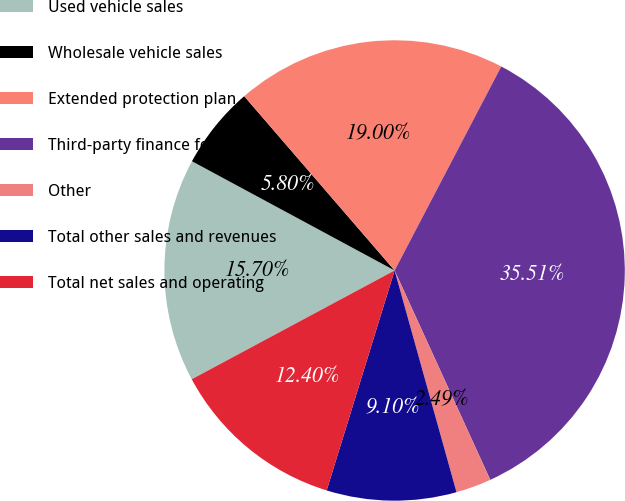Convert chart to OTSL. <chart><loc_0><loc_0><loc_500><loc_500><pie_chart><fcel>Used vehicle sales<fcel>Wholesale vehicle sales<fcel>Extended protection plan<fcel>Third-party finance fees net<fcel>Other<fcel>Total other sales and revenues<fcel>Total net sales and operating<nl><fcel>15.7%<fcel>5.8%<fcel>19.0%<fcel>35.51%<fcel>2.49%<fcel>9.1%<fcel>12.4%<nl></chart> 